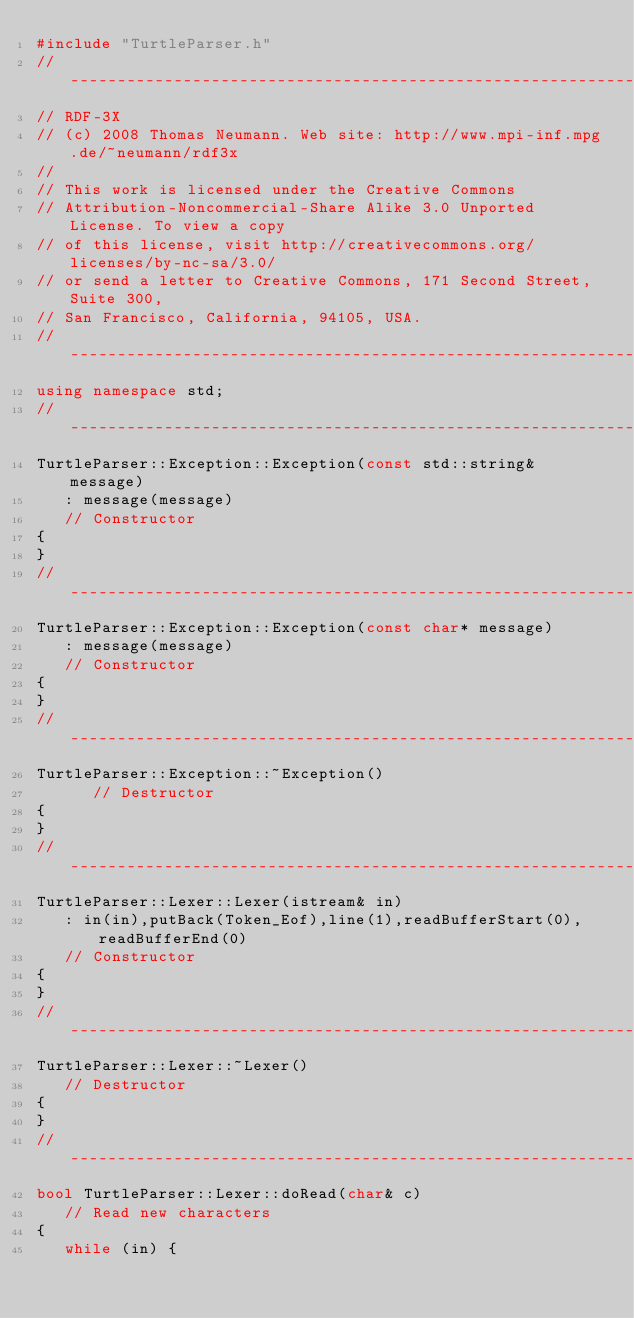Convert code to text. <code><loc_0><loc_0><loc_500><loc_500><_C++_>#include "TurtleParser.h"
//---------------------------------------------------------------------------
// RDF-3X
// (c) 2008 Thomas Neumann. Web site: http://www.mpi-inf.mpg.de/~neumann/rdf3x
//
// This work is licensed under the Creative Commons
// Attribution-Noncommercial-Share Alike 3.0 Unported License. To view a copy
// of this license, visit http://creativecommons.org/licenses/by-nc-sa/3.0/
// or send a letter to Creative Commons, 171 Second Street, Suite 300,
// San Francisco, California, 94105, USA.
//---------------------------------------------------------------------------
using namespace std;
//---------------------------------------------------------------------------
TurtleParser::Exception::Exception(const std::string& message)
   : message(message)
   // Constructor
{
}
//---------------------------------------------------------------------------
TurtleParser::Exception::Exception(const char* message)
   : message(message)
   // Constructor
{
}
//---------------------------------------------------------------------------
TurtleParser::Exception::~Exception()
      // Destructor
{
}
//---------------------------------------------------------------------------
TurtleParser::Lexer::Lexer(istream& in)
   : in(in),putBack(Token_Eof),line(1),readBufferStart(0),readBufferEnd(0)
   // Constructor
{
}
//---------------------------------------------------------------------------
TurtleParser::Lexer::~Lexer()
   // Destructor
{
}
//---------------------------------------------------------------------------
bool TurtleParser::Lexer::doRead(char& c)
   // Read new characters
{
   while (in) {</code> 